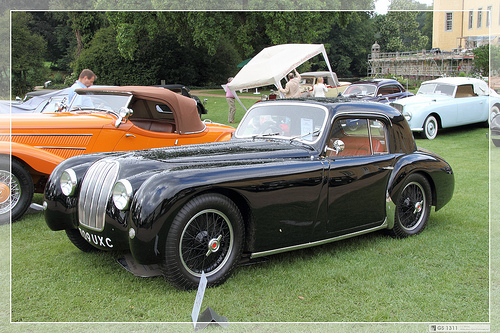<image>
Is the car behind the car? No. The car is not behind the car. From this viewpoint, the car appears to be positioned elsewhere in the scene. Is there a car to the right of the black car? Yes. From this viewpoint, the car is positioned to the right side relative to the black car. 